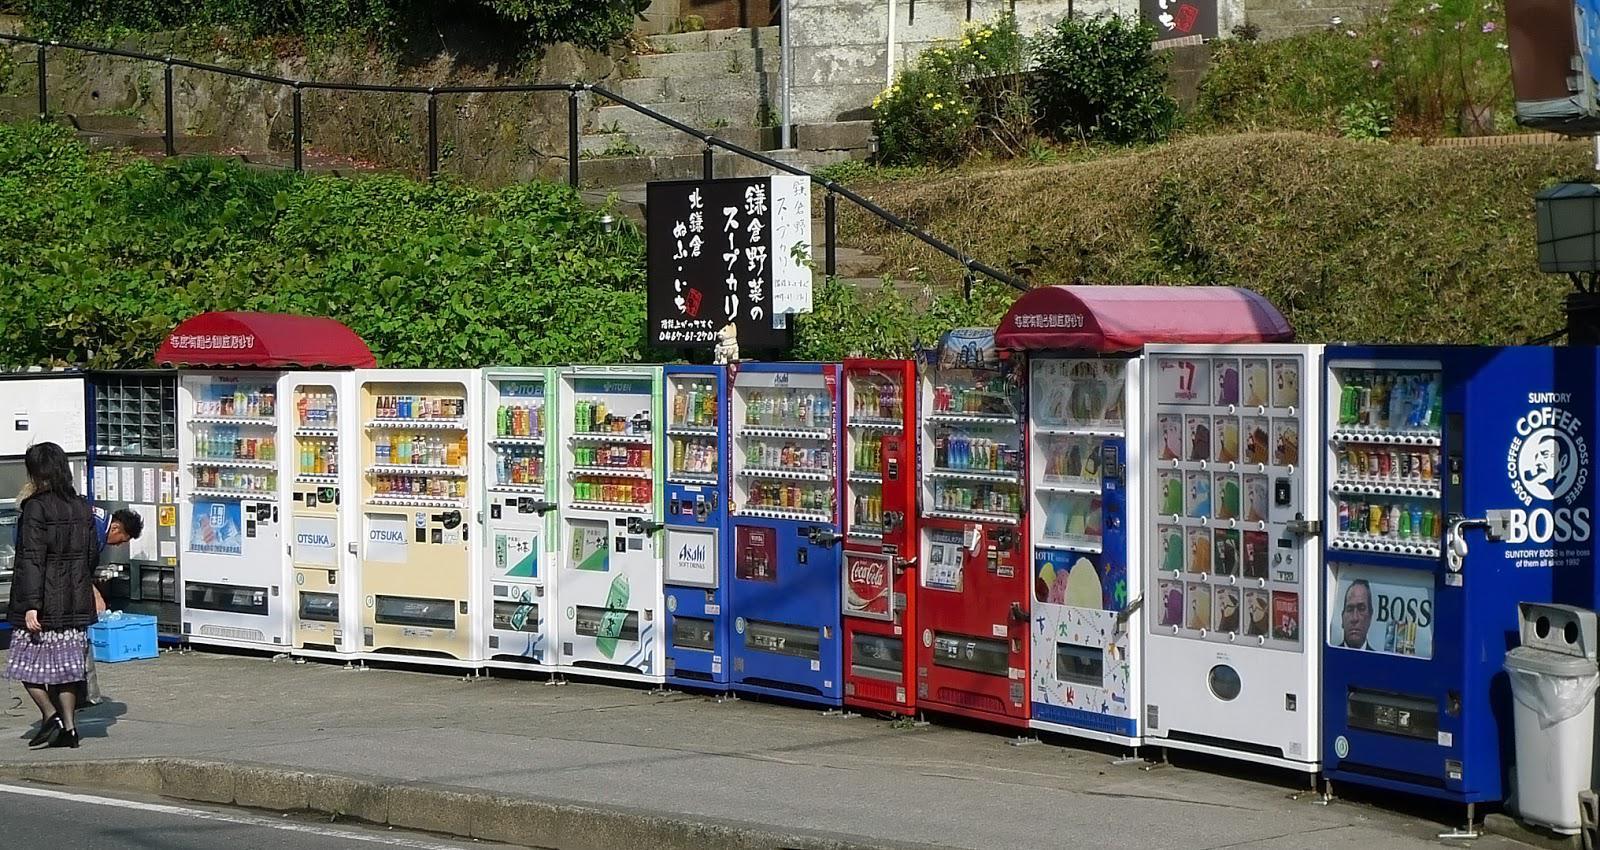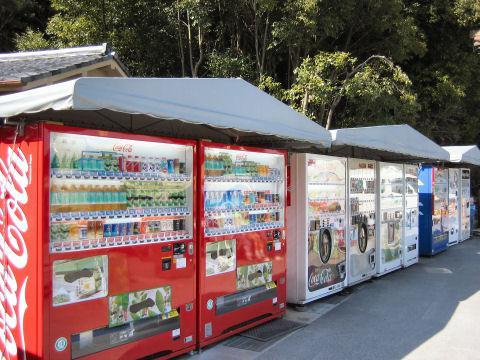The first image is the image on the left, the second image is the image on the right. For the images shown, is this caption "Red canapes cover some of the machines outside." true? Answer yes or no. Yes. The first image is the image on the left, the second image is the image on the right. Analyze the images presented: Is the assertion "Each image depicts a long row of outdoor red, white, and blue vending machines parked in front of a green area, with pavement in front." valid? Answer yes or no. Yes. 